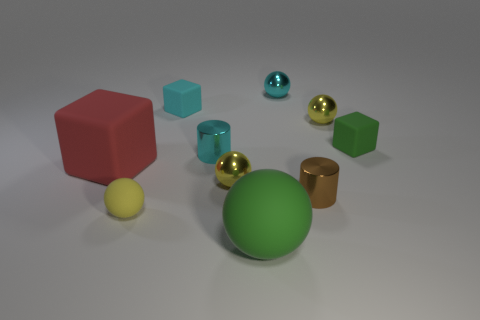What materials seem to be depicted in this array of objects? The image presents a collection of objects that appear to be made of materials with different finishes. The shiny spheres and cylinders suggest a metallic finish, while the cubes and the large sphere seem to have a matte or plastic-like appearance. 